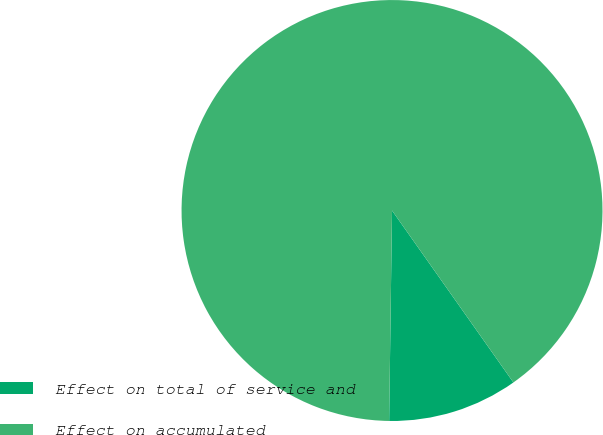Convert chart to OTSL. <chart><loc_0><loc_0><loc_500><loc_500><pie_chart><fcel>Effect on total of service and<fcel>Effect on accumulated<nl><fcel>10.0%<fcel>90.0%<nl></chart> 